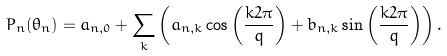<formula> <loc_0><loc_0><loc_500><loc_500>P _ { n } ( \theta _ { n } ) = a _ { n , 0 } + \sum _ { k } \left ( a _ { n , k } \cos \left ( \frac { k 2 \pi } { q } \right ) + b _ { n , k } \sin \left ( \frac { k 2 \pi } { q } \right ) \right ) .</formula> 